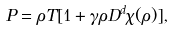Convert formula to latex. <formula><loc_0><loc_0><loc_500><loc_500>P = \rho T [ 1 + \gamma \rho D ^ { d } \chi ( \rho ) ] ,</formula> 